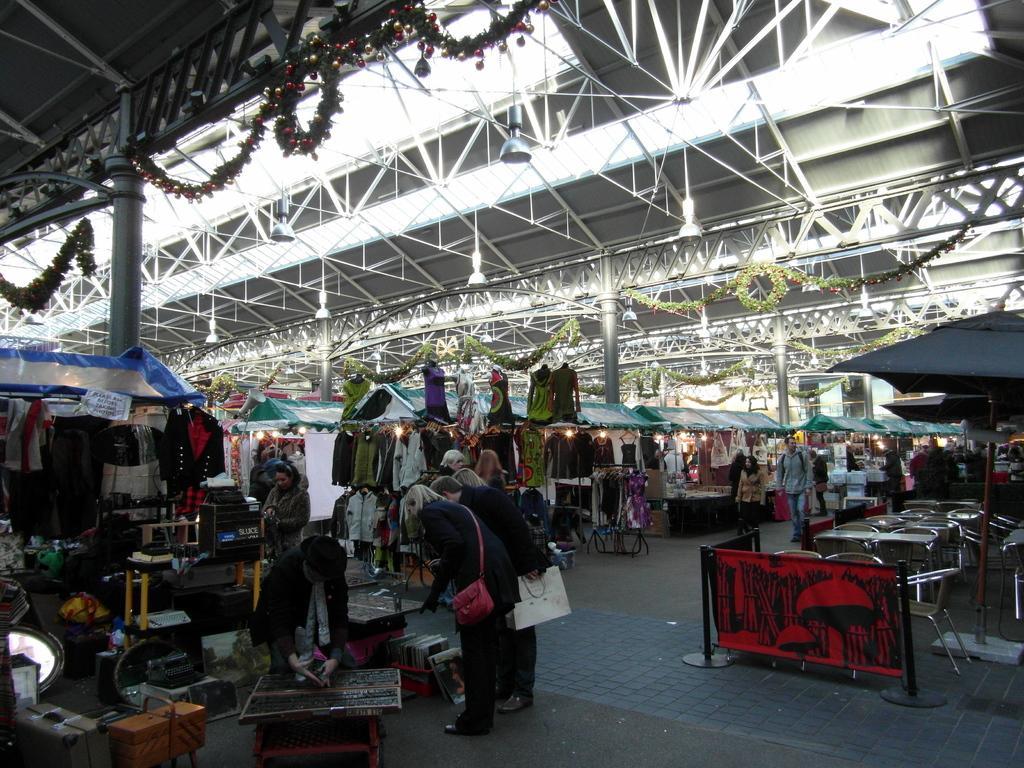How would you summarize this image in a sentence or two? In this image I can see group of people, some are walking and some are standing. I can also see few clothes in multi color, few sheds and lights and I can also see few poles and few decorative items. 